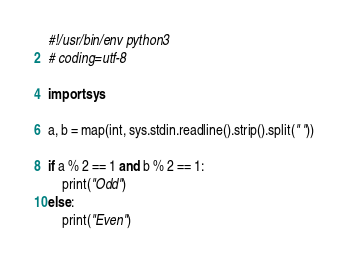<code> <loc_0><loc_0><loc_500><loc_500><_Python_>#!/usr/bin/env python3
# coding=utf-8

import sys

a, b = map(int, sys.stdin.readline().strip().split(" "))

if a % 2 == 1 and b % 2 == 1:
    print("Odd")
else:
    print("Even")
</code> 